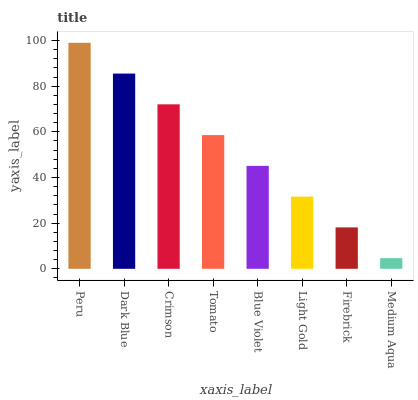Is Medium Aqua the minimum?
Answer yes or no. Yes. Is Peru the maximum?
Answer yes or no. Yes. Is Dark Blue the minimum?
Answer yes or no. No. Is Dark Blue the maximum?
Answer yes or no. No. Is Peru greater than Dark Blue?
Answer yes or no. Yes. Is Dark Blue less than Peru?
Answer yes or no. Yes. Is Dark Blue greater than Peru?
Answer yes or no. No. Is Peru less than Dark Blue?
Answer yes or no. No. Is Tomato the high median?
Answer yes or no. Yes. Is Blue Violet the low median?
Answer yes or no. Yes. Is Dark Blue the high median?
Answer yes or no. No. Is Medium Aqua the low median?
Answer yes or no. No. 